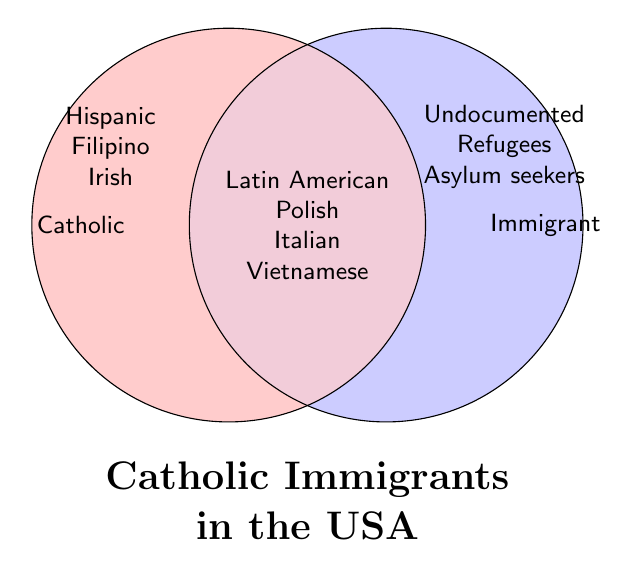What are the two main categories in the figure? There are two main categories labeled "Catholic" on the left circle and "Immigrant" on the right circle.
Answer: Catholic and Immigrant Which groups fall under both categories in the figure? The center of the Venn Diagram includes "Latin American Catholics", "Polish Catholics", "Italian Catholics", and "Vietnamese Catholics" indicating they belong to both Catholic and Immigrant categories.
Answer: Latin American, Polish, Italian, Vietnamese How many groups belong exclusively to the "Catholic" category? The left circle lists only three groups: "Hispanic immigrants", "Filipino immigrants", and "Irish immigrants", so there are three groups exclusive to the "Catholic" category.
Answer: Three What is one example of groups classified exclusively as "Immigrant" in the figure? In the right circle, there are groups such as "Undocumented Catholics", "Catholic refugees", and "Catholic asylum seekers" which are examples exclusive to the "Immigrant" category.
Answer: Undocumented Catholics (or others) How many groups are listed in total in the figure? Summing up all the groups from each section: three from "Catholic", three from "Immigrant", and four from the intersection, gives a total of 10 groups.
Answer: Ten Compare the number of groups exclusive to "Catholic" vs. the number of groups exclusive to "Immigrant". Which is greater? "Catholic" has three exclusive groups while "Immigrant" also has three exclusive groups, so they are equal.
Answer: Equal What color represents the overlap of the two categories in the figure? The overlapping section in the Venn Diagram is filled with a mix of the colors from the "Catholic" and "Immigrant" categories, resulting in purple.
Answer: Purple List the names of groups that appear only in one circle without overlapping. In the Catholic circle: "Hispanic immigrants", "Filipino immigrants", "Irish immigrants". In the Immigrant circle: "Undocumented Catholics", "Catholic refugees", "Catholic asylum seekers".
Answer: Hispanic, Filipino, Irish, Undocumented Catholics, Refugees, Asylum seekers 